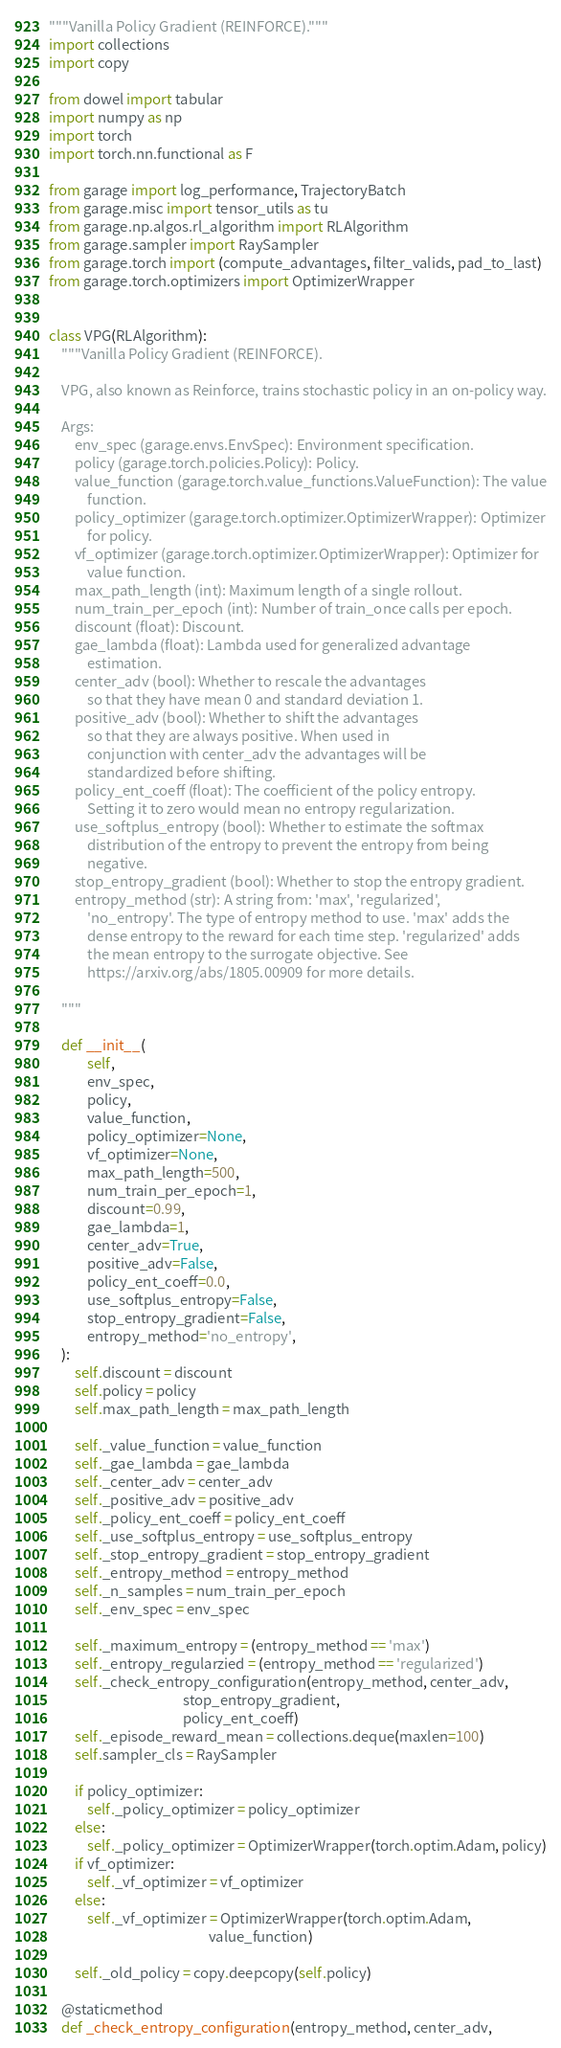Convert code to text. <code><loc_0><loc_0><loc_500><loc_500><_Python_>"""Vanilla Policy Gradient (REINFORCE)."""
import collections
import copy

from dowel import tabular
import numpy as np
import torch
import torch.nn.functional as F

from garage import log_performance, TrajectoryBatch
from garage.misc import tensor_utils as tu
from garage.np.algos.rl_algorithm import RLAlgorithm
from garage.sampler import RaySampler
from garage.torch import (compute_advantages, filter_valids, pad_to_last)
from garage.torch.optimizers import OptimizerWrapper


class VPG(RLAlgorithm):
    """Vanilla Policy Gradient (REINFORCE).

    VPG, also known as Reinforce, trains stochastic policy in an on-policy way.

    Args:
        env_spec (garage.envs.EnvSpec): Environment specification.
        policy (garage.torch.policies.Policy): Policy.
        value_function (garage.torch.value_functions.ValueFunction): The value
            function.
        policy_optimizer (garage.torch.optimizer.OptimizerWrapper): Optimizer
            for policy.
        vf_optimizer (garage.torch.optimizer.OptimizerWrapper): Optimizer for
            value function.
        max_path_length (int): Maximum length of a single rollout.
        num_train_per_epoch (int): Number of train_once calls per epoch.
        discount (float): Discount.
        gae_lambda (float): Lambda used for generalized advantage
            estimation.
        center_adv (bool): Whether to rescale the advantages
            so that they have mean 0 and standard deviation 1.
        positive_adv (bool): Whether to shift the advantages
            so that they are always positive. When used in
            conjunction with center_adv the advantages will be
            standardized before shifting.
        policy_ent_coeff (float): The coefficient of the policy entropy.
            Setting it to zero would mean no entropy regularization.
        use_softplus_entropy (bool): Whether to estimate the softmax
            distribution of the entropy to prevent the entropy from being
            negative.
        stop_entropy_gradient (bool): Whether to stop the entropy gradient.
        entropy_method (str): A string from: 'max', 'regularized',
            'no_entropy'. The type of entropy method to use. 'max' adds the
            dense entropy to the reward for each time step. 'regularized' adds
            the mean entropy to the surrogate objective. See
            https://arxiv.org/abs/1805.00909 for more details.

    """

    def __init__(
            self,
            env_spec,
            policy,
            value_function,
            policy_optimizer=None,
            vf_optimizer=None,
            max_path_length=500,
            num_train_per_epoch=1,
            discount=0.99,
            gae_lambda=1,
            center_adv=True,
            positive_adv=False,
            policy_ent_coeff=0.0,
            use_softplus_entropy=False,
            stop_entropy_gradient=False,
            entropy_method='no_entropy',
    ):
        self.discount = discount
        self.policy = policy
        self.max_path_length = max_path_length

        self._value_function = value_function
        self._gae_lambda = gae_lambda
        self._center_adv = center_adv
        self._positive_adv = positive_adv
        self._policy_ent_coeff = policy_ent_coeff
        self._use_softplus_entropy = use_softplus_entropy
        self._stop_entropy_gradient = stop_entropy_gradient
        self._entropy_method = entropy_method
        self._n_samples = num_train_per_epoch
        self._env_spec = env_spec

        self._maximum_entropy = (entropy_method == 'max')
        self._entropy_regularzied = (entropy_method == 'regularized')
        self._check_entropy_configuration(entropy_method, center_adv,
                                          stop_entropy_gradient,
                                          policy_ent_coeff)
        self._episode_reward_mean = collections.deque(maxlen=100)
        self.sampler_cls = RaySampler

        if policy_optimizer:
            self._policy_optimizer = policy_optimizer
        else:
            self._policy_optimizer = OptimizerWrapper(torch.optim.Adam, policy)
        if vf_optimizer:
            self._vf_optimizer = vf_optimizer
        else:
            self._vf_optimizer = OptimizerWrapper(torch.optim.Adam,
                                                  value_function)

        self._old_policy = copy.deepcopy(self.policy)

    @staticmethod
    def _check_entropy_configuration(entropy_method, center_adv,</code> 